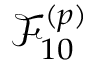<formula> <loc_0><loc_0><loc_500><loc_500>\mathcal { F } _ { 1 0 } ^ { ( p ) }</formula> 